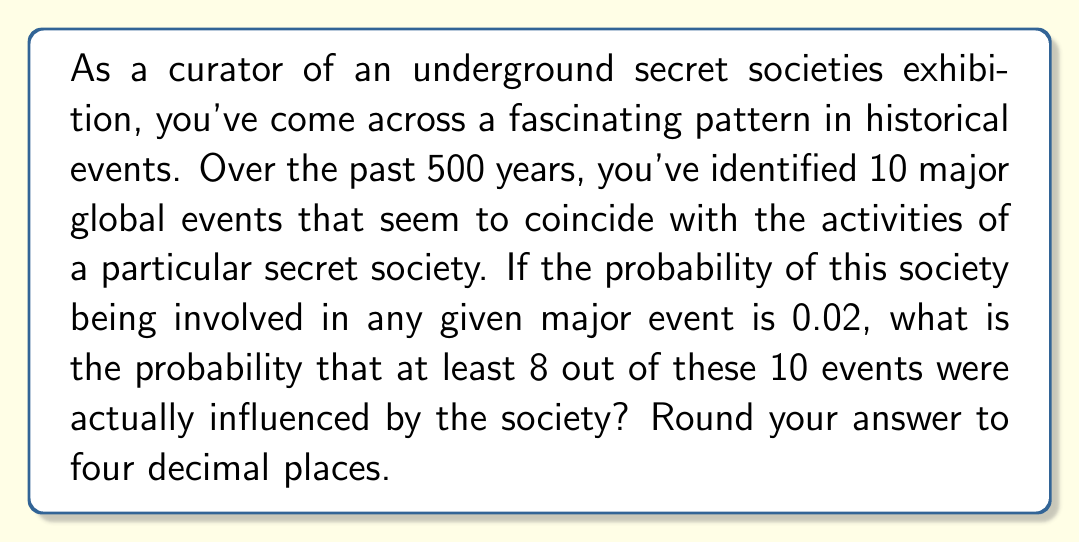Help me with this question. To solve this problem, we need to use the binomial probability distribution. Let's break it down step-by-step:

1) We have n = 10 events, and we're looking for the probability of 8, 9, or 10 of these events being influenced by the society.

2) The probability of the society influencing an event is p = 0.02.

3) We need to calculate P(X ≥ 8), where X is the number of events influenced by the society.

4) This can be expressed as:

   P(X ≥ 8) = P(X = 8) + P(X = 9) + P(X = 10)

5) We use the binomial probability formula:

   $$P(X = k) = \binom{n}{k} p^k (1-p)^{n-k}$$

   where $\binom{n}{k}$ is the binomial coefficient.

6) Let's calculate each probability:

   For k = 8:
   $$P(X = 8) = \binom{10}{8} (0.02)^8 (0.98)^2 = 45 \cdot (0.02)^8 \cdot (0.98)^2 = 1.5408 \times 10^{-11}$$

   For k = 9:
   $$P(X = 9) = \binom{10}{9} (0.02)^9 (0.98)^1 = 10 \cdot (0.02)^9 \cdot (0.98)^1 = 3.1447 \times 10^{-13}$$

   For k = 10:
   $$P(X = 10) = \binom{10}{10} (0.02)^{10} (0.98)^0 = 1 \cdot (0.02)^{10} = 1.0240 \times 10^{-15}$$

7) Sum these probabilities:

   P(X ≥ 8) = 1.5408 × 10^(-11) + 3.1447 × 10^(-13) + 1.0240 × 10^(-15) = 1.5723 × 10^(-11)

8) Rounding to four decimal places: 0.0000
Answer: 0.0000 